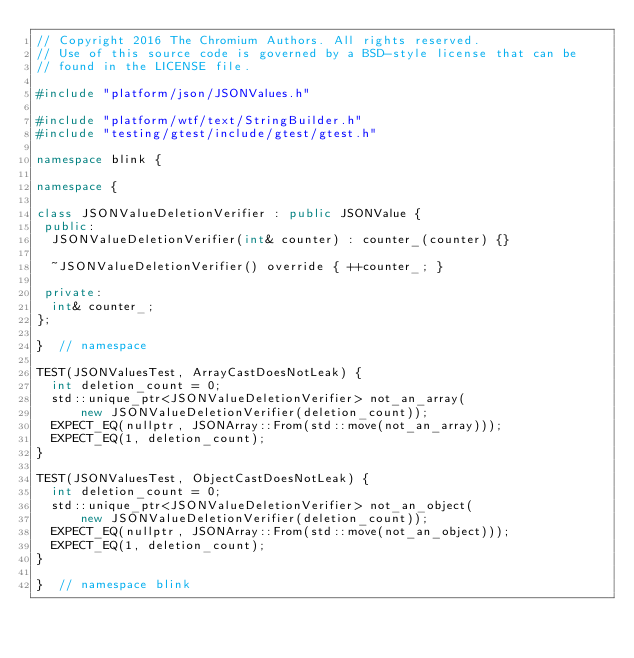<code> <loc_0><loc_0><loc_500><loc_500><_C++_>// Copyright 2016 The Chromium Authors. All rights reserved.
// Use of this source code is governed by a BSD-style license that can be
// found in the LICENSE file.

#include "platform/json/JSONValues.h"

#include "platform/wtf/text/StringBuilder.h"
#include "testing/gtest/include/gtest/gtest.h"

namespace blink {

namespace {

class JSONValueDeletionVerifier : public JSONValue {
 public:
  JSONValueDeletionVerifier(int& counter) : counter_(counter) {}

  ~JSONValueDeletionVerifier() override { ++counter_; }

 private:
  int& counter_;
};

}  // namespace

TEST(JSONValuesTest, ArrayCastDoesNotLeak) {
  int deletion_count = 0;
  std::unique_ptr<JSONValueDeletionVerifier> not_an_array(
      new JSONValueDeletionVerifier(deletion_count));
  EXPECT_EQ(nullptr, JSONArray::From(std::move(not_an_array)));
  EXPECT_EQ(1, deletion_count);
}

TEST(JSONValuesTest, ObjectCastDoesNotLeak) {
  int deletion_count = 0;
  std::unique_ptr<JSONValueDeletionVerifier> not_an_object(
      new JSONValueDeletionVerifier(deletion_count));
  EXPECT_EQ(nullptr, JSONArray::From(std::move(not_an_object)));
  EXPECT_EQ(1, deletion_count);
}

}  // namespace blink
</code> 